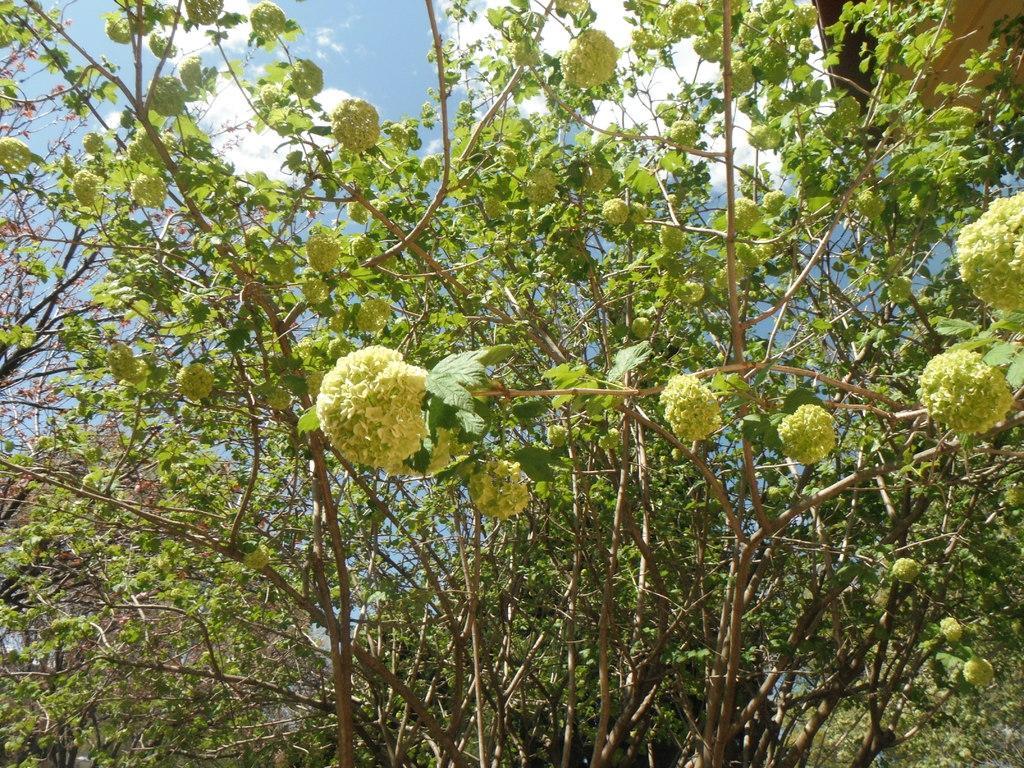Please provide a concise description of this image. In this picture we can see a few flowers on plant. Sky is blue in color and cloudy. 